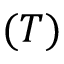<formula> <loc_0><loc_0><loc_500><loc_500>( T )</formula> 